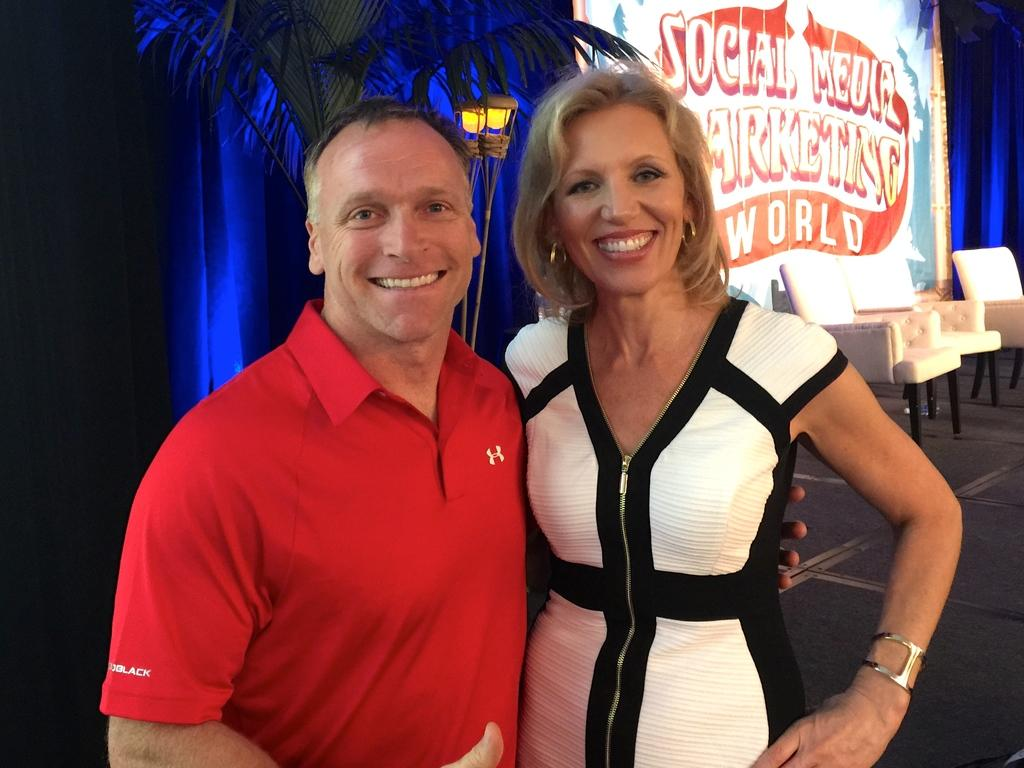<image>
Summarize the visual content of the image. A man and woman have their arm around one another and a sign behind them says Social Media Marketing World. 